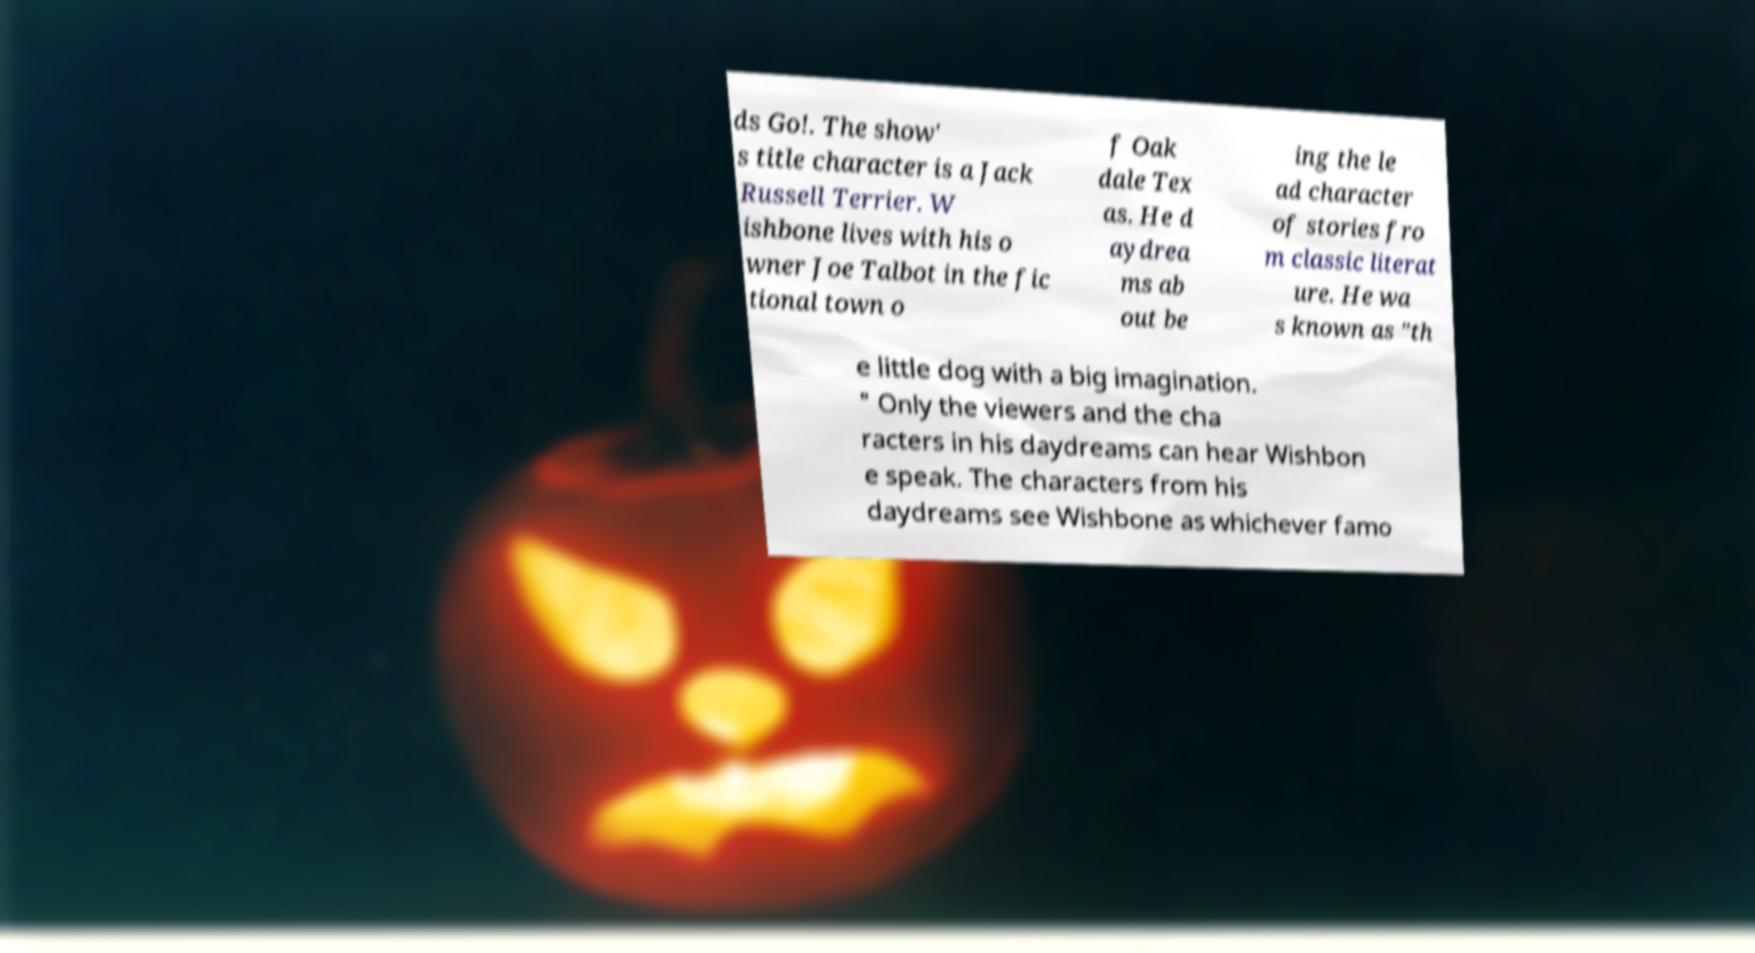Could you extract and type out the text from this image? ds Go!. The show' s title character is a Jack Russell Terrier. W ishbone lives with his o wner Joe Talbot in the fic tional town o f Oak dale Tex as. He d aydrea ms ab out be ing the le ad character of stories fro m classic literat ure. He wa s known as "th e little dog with a big imagination. " Only the viewers and the cha racters in his daydreams can hear Wishbon e speak. The characters from his daydreams see Wishbone as whichever famo 